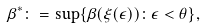<formula> <loc_0><loc_0><loc_500><loc_500>\beta ^ { * } \colon = \sup \{ \beta ( \xi ( \epsilon ) ) \colon \epsilon < \theta \} ,</formula> 